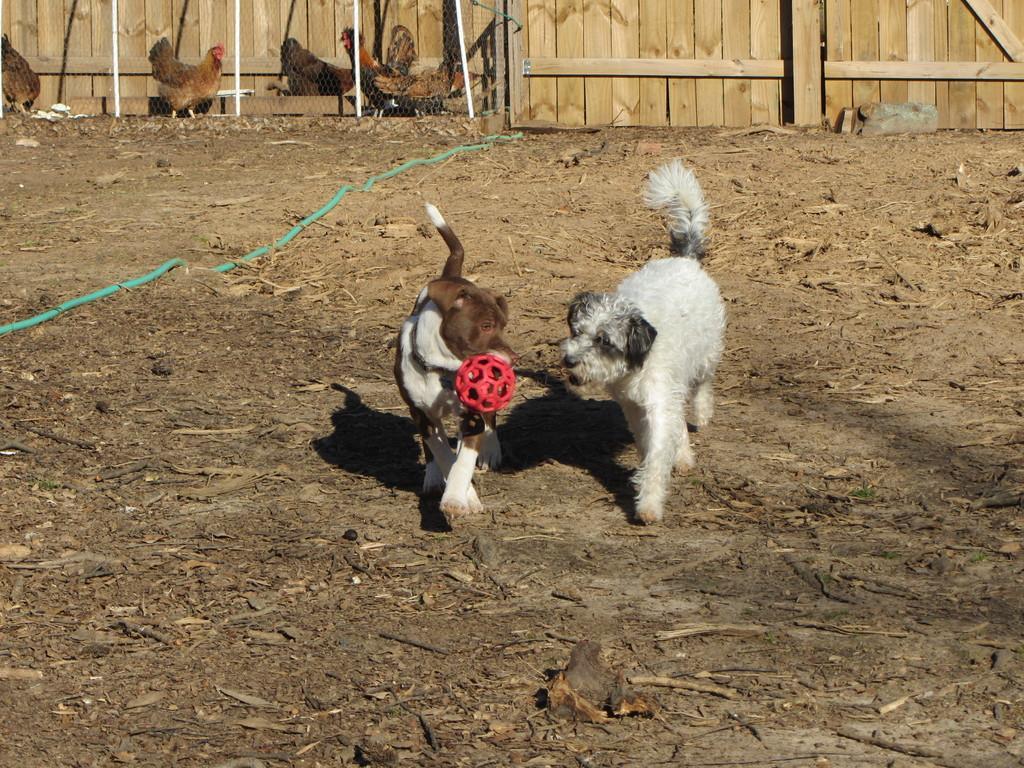Can you describe this image briefly? In this image there are dogs on a land, in the background there are hens and there is a wooden land. 